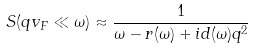Convert formula to latex. <formula><loc_0><loc_0><loc_500><loc_500>& S ( q v _ { F } \ll \omega ) \approx \frac { 1 } { \omega - r ( \omega ) + i d ( \omega ) q ^ { 2 } }</formula> 